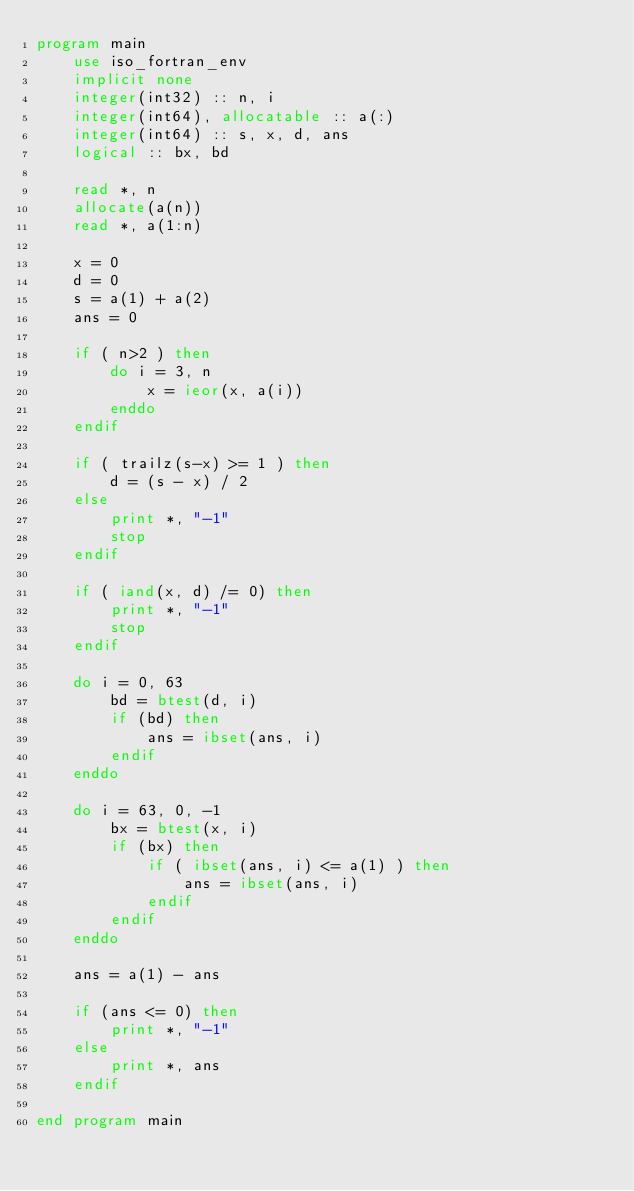<code> <loc_0><loc_0><loc_500><loc_500><_FORTRAN_>program main
    use iso_fortran_env
    implicit none
    integer(int32) :: n, i
    integer(int64), allocatable :: a(:)
    integer(int64) :: s, x, d, ans
    logical :: bx, bd

    read *, n
    allocate(a(n))
    read *, a(1:n)

    x = 0
    d = 0
    s = a(1) + a(2)
    ans = 0

    if ( n>2 ) then
        do i = 3, n
            x = ieor(x, a(i))
        enddo
    endif

    if ( trailz(s-x) >= 1 ) then
        d = (s - x) / 2
    else
        print *, "-1"
        stop
    endif

    if ( iand(x, d) /= 0) then
        print *, "-1"
        stop
    endif

    do i = 0, 63
        bd = btest(d, i)
        if (bd) then
            ans = ibset(ans, i)
        endif
    enddo

    do i = 63, 0, -1
        bx = btest(x, i)
        if (bx) then
            if ( ibset(ans, i) <= a(1) ) then
                ans = ibset(ans, i)
            endif
        endif
    enddo

    ans = a(1) - ans

    if (ans <= 0) then
        print *, "-1"
    else
        print *, ans
    endif

end program main
</code> 